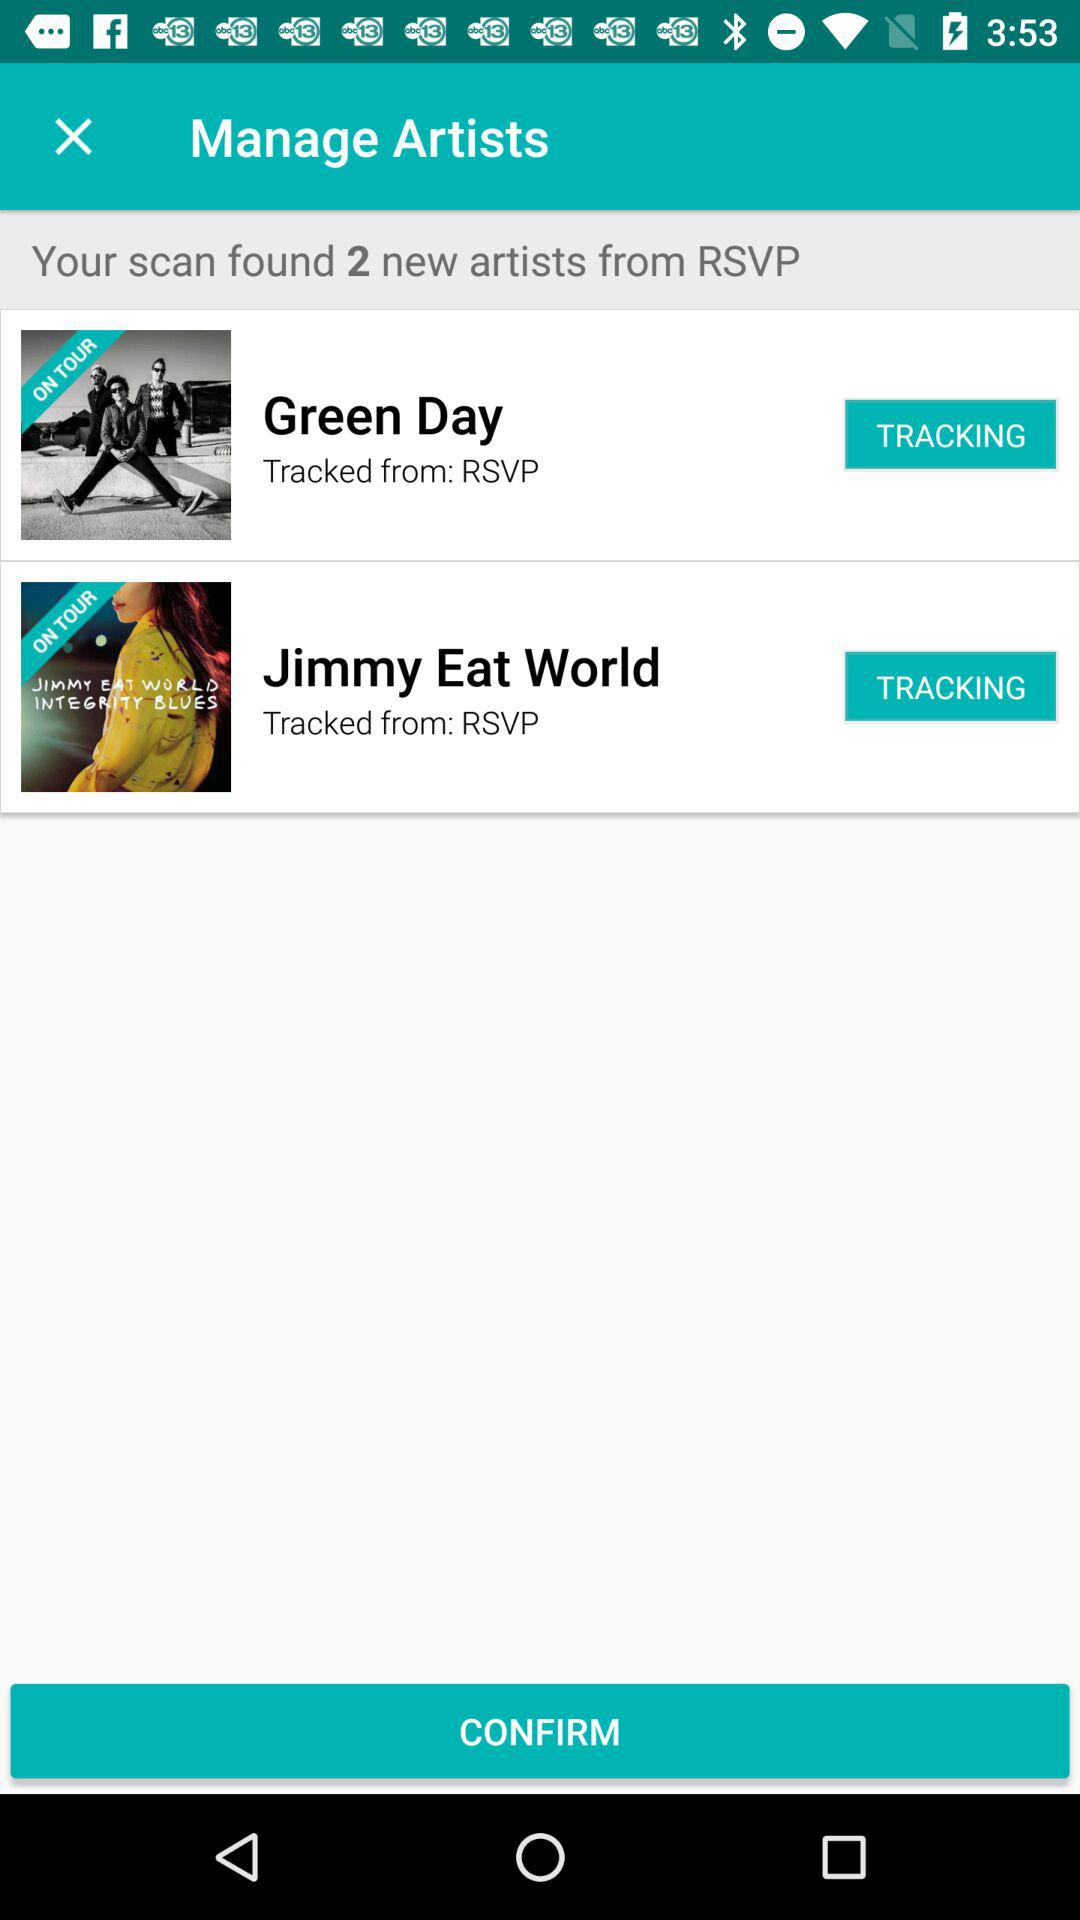How many artists were tracked from RSVP? 2 